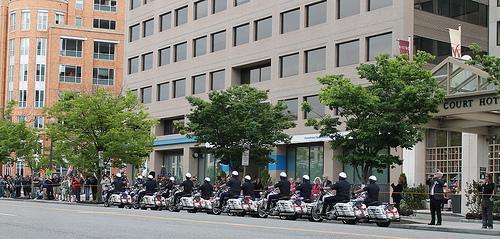How many buildings are in the picture?
Give a very brief answer. 2. 